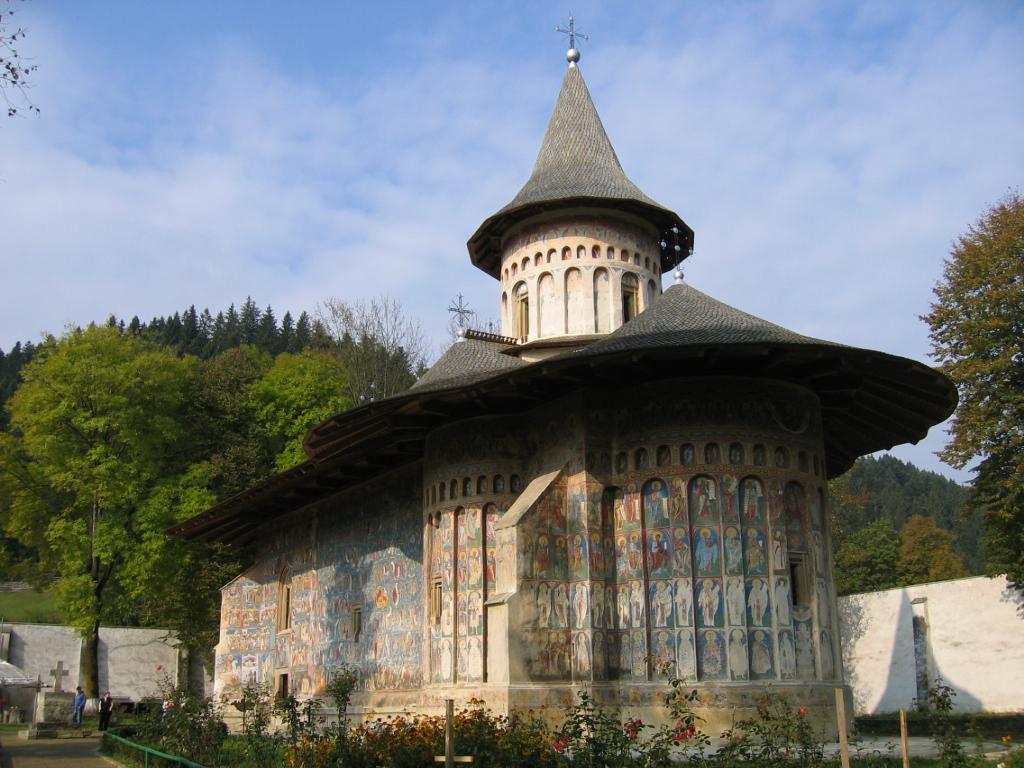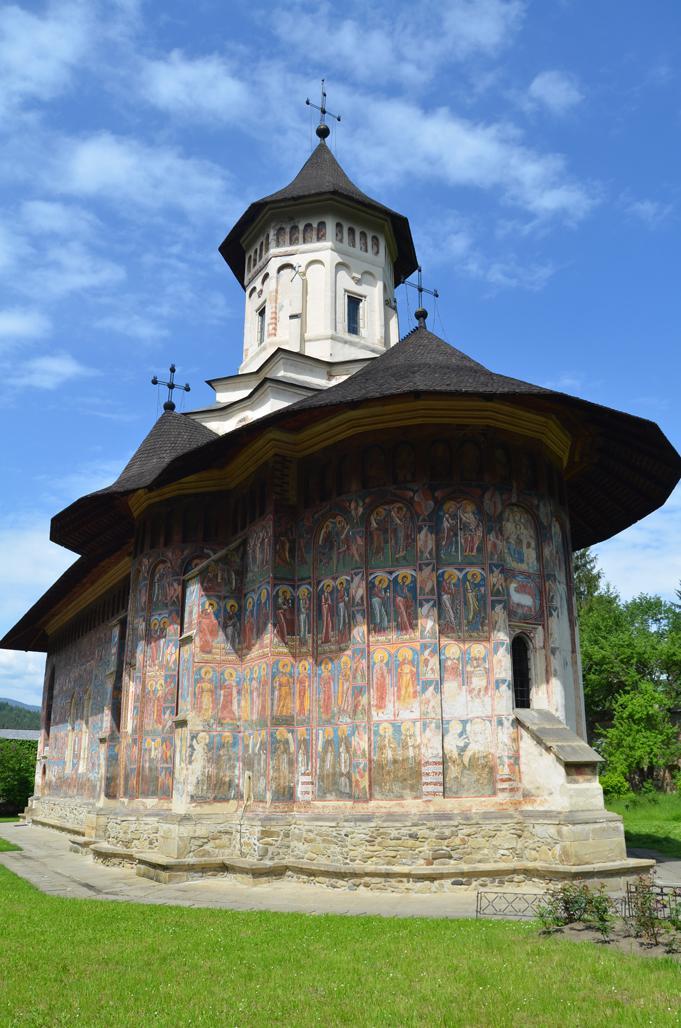The first image is the image on the left, the second image is the image on the right. For the images displayed, is the sentence "You can see a lawn surrounding the church in both images." factually correct? Answer yes or no. No. 